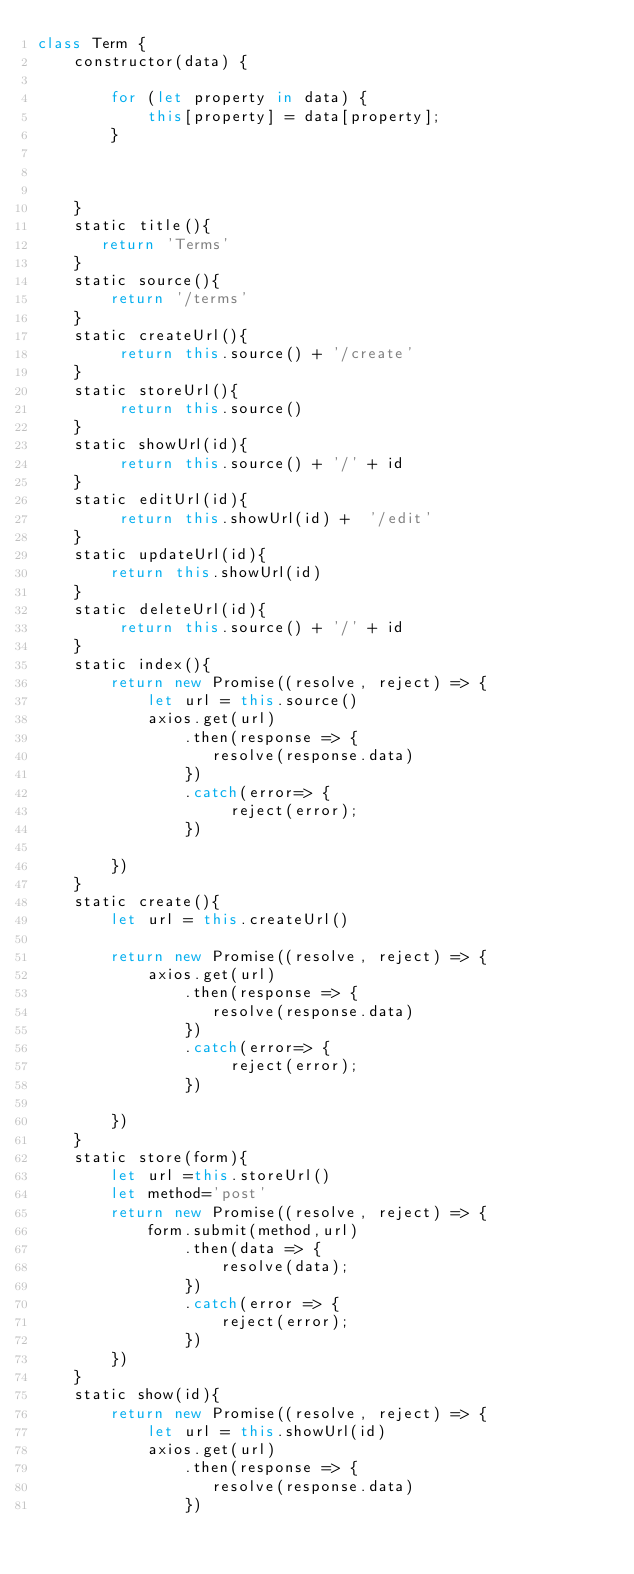Convert code to text. <code><loc_0><loc_0><loc_500><loc_500><_JavaScript_>class Term {
    constructor(data) {
       
        for (let property in data) {
            this[property] = data[property];
        }

       

    }
    static title(){
       return 'Terms'
    }
    static source(){
        return '/terms'
    }
    static createUrl(){
         return this.source() + '/create' 
    }
    static storeUrl(){
         return this.source()
    }
    static showUrl(id){
         return this.source() + '/' + id
    }
    static editUrl(id){
         return this.showUrl(id) +  '/edit'
    }
    static updateUrl(id){
        return this.showUrl(id)
    }
    static deleteUrl(id){
         return this.source() + '/' + id
    }
    static index(){
        return new Promise((resolve, reject) => {
            let url = this.source() 
            axios.get(url)
                .then(response => {
                   resolve(response.data)
                })
                .catch(error=> {
                     reject(error);
                })
           
        })
    }
    static create(){
        let url = this.createUrl() 
      
        return new Promise((resolve, reject) => {
            axios.get(url)
                .then(response => {
                   resolve(response.data)
                })
                .catch(error=> {
                     reject(error);
                })
           
        })
    }
    static store(form){
        let url =this.storeUrl() 
        let method='post'
        return new Promise((resolve, reject) => {
            form.submit(method,url)
                .then(data => {
                    resolve(data);
                })
                .catch(error => {
                    reject(error);
                })
        })
    }
    static show(id){
        return new Promise((resolve, reject) => {
            let url = this.showUrl(id) 
            axios.get(url)
                .then(response => {
                   resolve(response.data)
                })</code> 